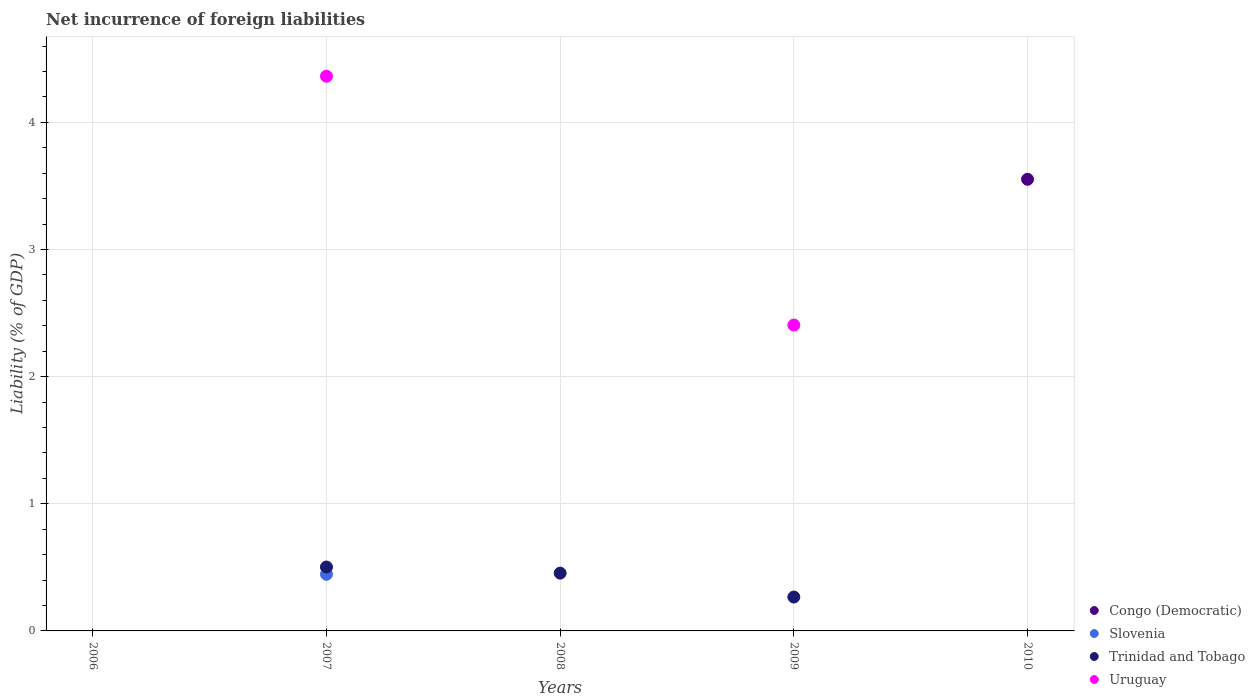What is the net incurrence of foreign liabilities in Trinidad and Tobago in 2006?
Make the answer very short. 0. Across all years, what is the maximum net incurrence of foreign liabilities in Slovenia?
Your answer should be very brief. 0.45. Across all years, what is the minimum net incurrence of foreign liabilities in Uruguay?
Your response must be concise. 0. In which year was the net incurrence of foreign liabilities in Congo (Democratic) maximum?
Your answer should be very brief. 2010. What is the total net incurrence of foreign liabilities in Slovenia in the graph?
Your answer should be compact. 0.45. What is the difference between the net incurrence of foreign liabilities in Trinidad and Tobago in 2010 and the net incurrence of foreign liabilities in Uruguay in 2009?
Your answer should be compact. -2.41. What is the average net incurrence of foreign liabilities in Congo (Democratic) per year?
Give a very brief answer. 0.71. In the year 2007, what is the difference between the net incurrence of foreign liabilities in Uruguay and net incurrence of foreign liabilities in Trinidad and Tobago?
Your response must be concise. 3.86. In how many years, is the net incurrence of foreign liabilities in Trinidad and Tobago greater than 4.4 %?
Keep it short and to the point. 0. What is the difference between the highest and the second highest net incurrence of foreign liabilities in Trinidad and Tobago?
Make the answer very short. 0.05. What is the difference between the highest and the lowest net incurrence of foreign liabilities in Trinidad and Tobago?
Your answer should be compact. 0.5. In how many years, is the net incurrence of foreign liabilities in Congo (Democratic) greater than the average net incurrence of foreign liabilities in Congo (Democratic) taken over all years?
Provide a succinct answer. 1. Is it the case that in every year, the sum of the net incurrence of foreign liabilities in Uruguay and net incurrence of foreign liabilities in Slovenia  is greater than the sum of net incurrence of foreign liabilities in Trinidad and Tobago and net incurrence of foreign liabilities in Congo (Democratic)?
Offer a very short reply. No. Does the net incurrence of foreign liabilities in Congo (Democratic) monotonically increase over the years?
Ensure brevity in your answer.  Yes. How many dotlines are there?
Keep it short and to the point. 4. How many years are there in the graph?
Offer a very short reply. 5. What is the difference between two consecutive major ticks on the Y-axis?
Keep it short and to the point. 1. What is the title of the graph?
Make the answer very short. Net incurrence of foreign liabilities. What is the label or title of the Y-axis?
Your answer should be very brief. Liability (% of GDP). What is the Liability (% of GDP) in Congo (Democratic) in 2006?
Your answer should be compact. 0. What is the Liability (% of GDP) in Slovenia in 2006?
Give a very brief answer. 0. What is the Liability (% of GDP) in Trinidad and Tobago in 2006?
Give a very brief answer. 0. What is the Liability (% of GDP) in Uruguay in 2006?
Make the answer very short. 0. What is the Liability (% of GDP) of Congo (Democratic) in 2007?
Provide a succinct answer. 0. What is the Liability (% of GDP) of Slovenia in 2007?
Make the answer very short. 0.45. What is the Liability (% of GDP) of Trinidad and Tobago in 2007?
Give a very brief answer. 0.5. What is the Liability (% of GDP) in Uruguay in 2007?
Offer a very short reply. 4.36. What is the Liability (% of GDP) of Trinidad and Tobago in 2008?
Make the answer very short. 0.45. What is the Liability (% of GDP) in Uruguay in 2008?
Offer a very short reply. 0. What is the Liability (% of GDP) in Congo (Democratic) in 2009?
Provide a short and direct response. 0. What is the Liability (% of GDP) of Trinidad and Tobago in 2009?
Keep it short and to the point. 0.27. What is the Liability (% of GDP) of Uruguay in 2009?
Your answer should be very brief. 2.41. What is the Liability (% of GDP) in Congo (Democratic) in 2010?
Offer a very short reply. 3.55. What is the Liability (% of GDP) in Slovenia in 2010?
Offer a very short reply. 0. What is the Liability (% of GDP) of Trinidad and Tobago in 2010?
Give a very brief answer. 0. What is the Liability (% of GDP) in Uruguay in 2010?
Provide a succinct answer. 0. Across all years, what is the maximum Liability (% of GDP) of Congo (Democratic)?
Ensure brevity in your answer.  3.55. Across all years, what is the maximum Liability (% of GDP) of Slovenia?
Your answer should be very brief. 0.45. Across all years, what is the maximum Liability (% of GDP) of Trinidad and Tobago?
Ensure brevity in your answer.  0.5. Across all years, what is the maximum Liability (% of GDP) of Uruguay?
Your response must be concise. 4.36. Across all years, what is the minimum Liability (% of GDP) of Congo (Democratic)?
Provide a short and direct response. 0. Across all years, what is the minimum Liability (% of GDP) in Trinidad and Tobago?
Ensure brevity in your answer.  0. Across all years, what is the minimum Liability (% of GDP) of Uruguay?
Your response must be concise. 0. What is the total Liability (% of GDP) of Congo (Democratic) in the graph?
Your response must be concise. 3.55. What is the total Liability (% of GDP) of Slovenia in the graph?
Ensure brevity in your answer.  0.45. What is the total Liability (% of GDP) of Trinidad and Tobago in the graph?
Provide a succinct answer. 1.22. What is the total Liability (% of GDP) of Uruguay in the graph?
Your response must be concise. 6.77. What is the difference between the Liability (% of GDP) of Trinidad and Tobago in 2007 and that in 2008?
Your answer should be compact. 0.05. What is the difference between the Liability (% of GDP) of Trinidad and Tobago in 2007 and that in 2009?
Your answer should be very brief. 0.24. What is the difference between the Liability (% of GDP) in Uruguay in 2007 and that in 2009?
Ensure brevity in your answer.  1.96. What is the difference between the Liability (% of GDP) in Trinidad and Tobago in 2008 and that in 2009?
Offer a very short reply. 0.19. What is the difference between the Liability (% of GDP) in Slovenia in 2007 and the Liability (% of GDP) in Trinidad and Tobago in 2008?
Offer a terse response. -0.01. What is the difference between the Liability (% of GDP) in Slovenia in 2007 and the Liability (% of GDP) in Trinidad and Tobago in 2009?
Provide a short and direct response. 0.18. What is the difference between the Liability (% of GDP) of Slovenia in 2007 and the Liability (% of GDP) of Uruguay in 2009?
Offer a very short reply. -1.96. What is the difference between the Liability (% of GDP) in Trinidad and Tobago in 2007 and the Liability (% of GDP) in Uruguay in 2009?
Your answer should be very brief. -1.9. What is the difference between the Liability (% of GDP) of Trinidad and Tobago in 2008 and the Liability (% of GDP) of Uruguay in 2009?
Ensure brevity in your answer.  -1.95. What is the average Liability (% of GDP) of Congo (Democratic) per year?
Provide a succinct answer. 0.71. What is the average Liability (% of GDP) of Slovenia per year?
Provide a succinct answer. 0.09. What is the average Liability (% of GDP) of Trinidad and Tobago per year?
Make the answer very short. 0.24. What is the average Liability (% of GDP) in Uruguay per year?
Offer a very short reply. 1.35. In the year 2007, what is the difference between the Liability (% of GDP) in Slovenia and Liability (% of GDP) in Trinidad and Tobago?
Make the answer very short. -0.06. In the year 2007, what is the difference between the Liability (% of GDP) of Slovenia and Liability (% of GDP) of Uruguay?
Provide a short and direct response. -3.92. In the year 2007, what is the difference between the Liability (% of GDP) in Trinidad and Tobago and Liability (% of GDP) in Uruguay?
Make the answer very short. -3.86. In the year 2009, what is the difference between the Liability (% of GDP) in Trinidad and Tobago and Liability (% of GDP) in Uruguay?
Offer a very short reply. -2.14. What is the ratio of the Liability (% of GDP) in Trinidad and Tobago in 2007 to that in 2008?
Make the answer very short. 1.11. What is the ratio of the Liability (% of GDP) in Trinidad and Tobago in 2007 to that in 2009?
Ensure brevity in your answer.  1.89. What is the ratio of the Liability (% of GDP) of Uruguay in 2007 to that in 2009?
Make the answer very short. 1.81. What is the ratio of the Liability (% of GDP) of Trinidad and Tobago in 2008 to that in 2009?
Provide a short and direct response. 1.71. What is the difference between the highest and the second highest Liability (% of GDP) of Trinidad and Tobago?
Offer a terse response. 0.05. What is the difference between the highest and the lowest Liability (% of GDP) of Congo (Democratic)?
Ensure brevity in your answer.  3.55. What is the difference between the highest and the lowest Liability (% of GDP) in Slovenia?
Offer a terse response. 0.45. What is the difference between the highest and the lowest Liability (% of GDP) in Trinidad and Tobago?
Your answer should be very brief. 0.5. What is the difference between the highest and the lowest Liability (% of GDP) of Uruguay?
Give a very brief answer. 4.36. 